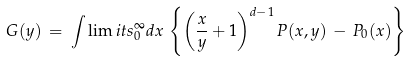<formula> <loc_0><loc_0><loc_500><loc_500>G ( y ) \, = \, \int \lim i t s _ { 0 } ^ { \infty } d x \, \left \{ \left ( \frac { x } { y } + 1 \right ) ^ { d - 1 } P ( x , y ) \, - \, P _ { 0 } ( x ) \right \}</formula> 